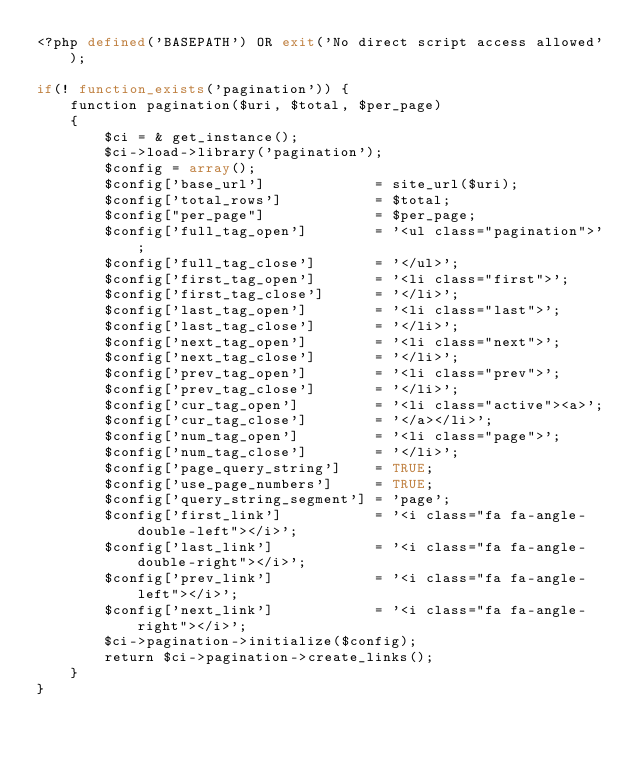<code> <loc_0><loc_0><loc_500><loc_500><_PHP_><?php defined('BASEPATH') OR exit('No direct script access allowed');

if(! function_exists('pagination')) {
    function pagination($uri, $total, $per_page)
    {
        $ci = & get_instance();
        $ci->load->library('pagination');
        $config = array();
        $config['base_url']             = site_url($uri);
        $config['total_rows']           = $total;
        $config["per_page"]             = $per_page;
        $config['full_tag_open']        = '<ul class="pagination">';
        $config['full_tag_close']       = '</ul>';
        $config['first_tag_open']       = '<li class="first">';
        $config['first_tag_close']      = '</li>';
        $config['last_tag_open']        = '<li class="last">';
        $config['last_tag_close']       = '</li>';
        $config['next_tag_open']        = '<li class="next">';
        $config['next_tag_close']       = '</li>';
        $config['prev_tag_open']        = '<li class="prev">';
        $config['prev_tag_close']       = '</li>';
        $config['cur_tag_open']         = '<li class="active"><a>';
        $config['cur_tag_close']        = '</a></li>';
        $config['num_tag_open']         = '<li class="page">';
        $config['num_tag_close']        = '</li>';
        $config['page_query_string']    = TRUE;
        $config['use_page_numbers']     = TRUE;
        $config['query_string_segment'] = 'page';
        $config['first_link']           = '<i class="fa fa-angle-double-left"></i>';
        $config['last_link']            = '<i class="fa fa-angle-double-right"></i>';
        $config['prev_link']            = '<i class="fa fa-angle-left"></i>';
        $config['next_link']            = '<i class="fa fa-angle-right"></i>';
        $ci->pagination->initialize($config);
        return $ci->pagination->create_links();
    }
}
</code> 